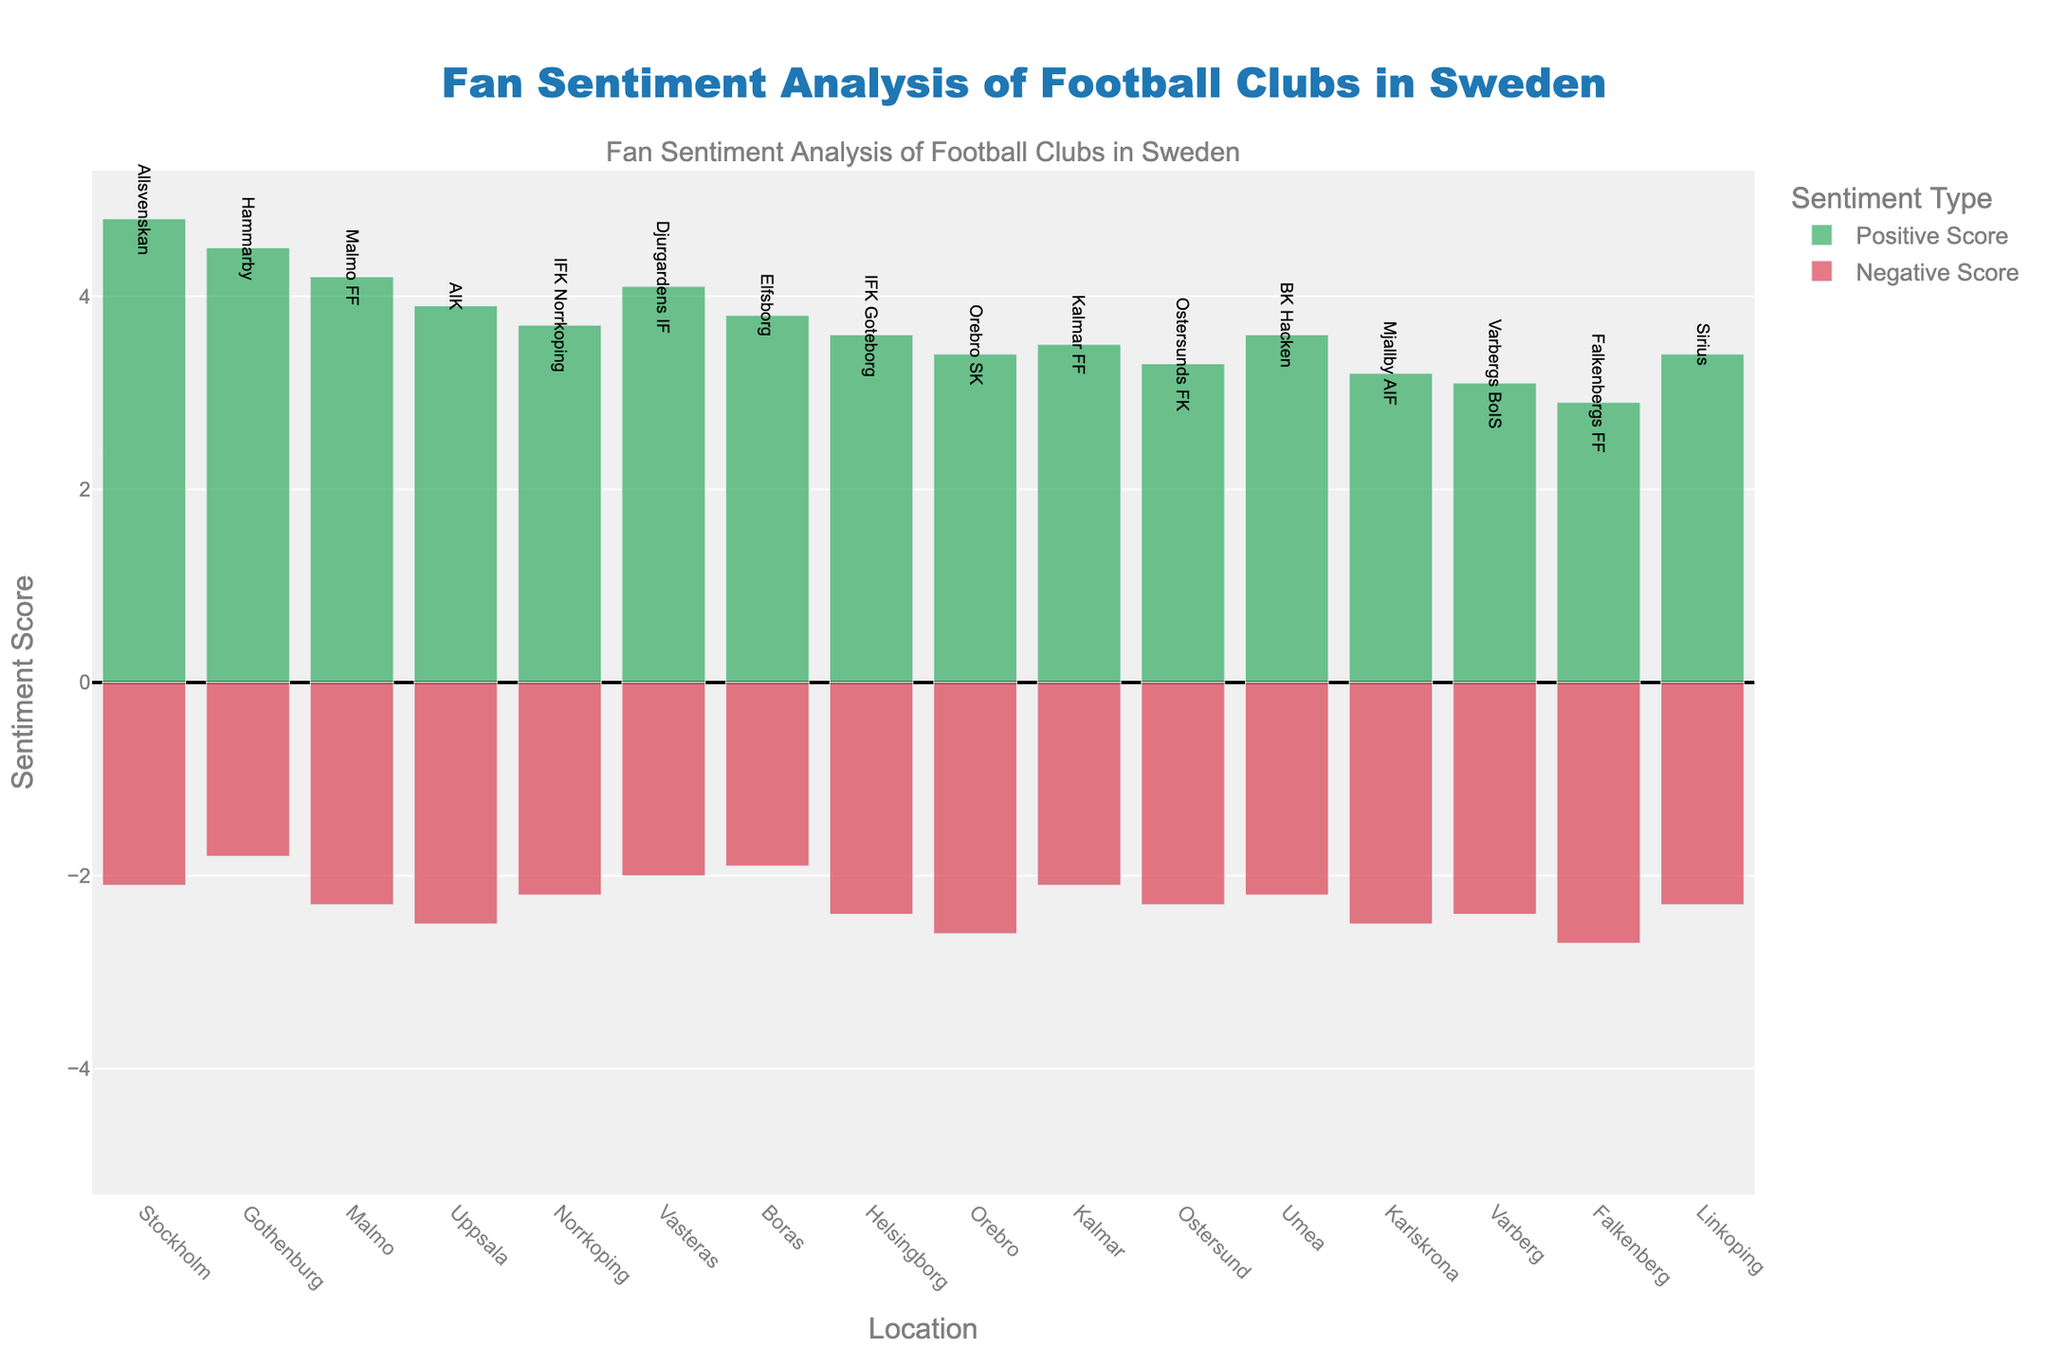Which location has the highest positive sentiment score? The location with the highest positive sentiment score is determined by looking for the tallest bar in the green bars. Stockholm has the tallest green bar representing a score of 4.8.
Answer: Stockholm What is the negative sentiment score at Malmo? To find the negative sentiment score at Malmo, look at the length of the red bar at the location Malmo. The bar representing negative sentiment score for Malmo extends to -2.3.
Answer: 2.3 Which club has a higher positive sentiment score, Djurgardens IF or AIK? To compare the positive sentiment scores, observe the heights of the green bars for Djurgardens IF (Vasteras) and AIK (Uppsala). Djurgardens IF has a score of 4.1 while AIK has a score of 3.9.
Answer: Djurgardens IF Is the negative sentiment score for Kalmar FF greater than that for Ostersunds FK? Compare the heights of the red bars for Kalmar (Kalmar FF) and Ostersund (Ostersunds FK). Kalmar's negative score is 2.1 and Ostersund's is 2.3, so Kalmar's score is lower.
Answer: No What is the total sentiment score (positive minus negative) for Hammarby? To find the total sentiment score for Hammarby, subtract the negative score from the positive score. Hammarby's positive score is 4.5 and its negative score is 1.8, so the total is 4.5 - 1.8 = 2.7.
Answer: 2.7 Which location has the lowest negative sentiment score and what is the score? The location with the smallest red bar has the lowest negative sentiment. Gothenburg (Hammarby) has the smallest red bar extending to -1.8.
Answer: Gothenburg, 1.8 What is the average positive sentiment score across all locations? To find the average positive sentiment, sum all the positive scores and divide by the number of locations. The positive scores are 4.8, 4.5, 4.2, 3.9, 3.7, 4.1, 3.8, 3.6, 3.4, 3.5, 3.3, 3.6, 3.2, 3.1, 2.9, 3.4. The sum is 57.1 and there are 16 locations, so the average is 57.1 / 16 = 3.57.
Answer: 3.57 Which clubs have positive sentiment scores greater than 4? The clubs with green bars taller than 4 are those with positive sentiment scores greater than 4. These clubs are AIK, Djurgardens IF, Allsvenskan, and Hammarby.
Answer: Allsvenskan, Hammarby, Malmo FF, Djurgardens IF What is the difference in negative sentiment scores between Falkenbergs FF and Varbergs BoIS? Subtract the negative score of Varbergs BoIS from that of Falkenbergs FF. Falkenbergs FF has a negative score of 2.7 and Varbergs BoIS has a score of 2.4. The difference is 2.7 - 2.4 = 0.3.
Answer: 0.3 Which club in Boras has what specific sentiment scores? Look for the club associated with Boras and note its sentiment scores. Boras represents Elfsborg, which has a positive sentiment score of 3.8 and a negative sentiment score of 1.9.
Answer: Elfsborg, Pos: 3.8, Neg: 1.9 